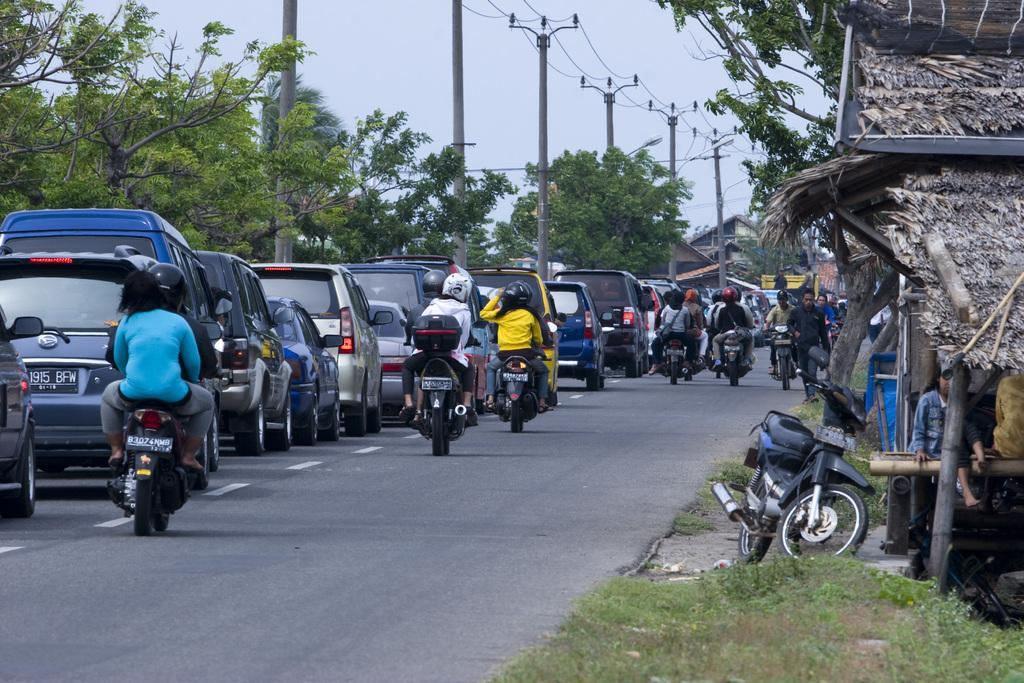What types of vehicles can be seen on the road in the image? Cars and bikes can be seen on the road in the image. What type of vegetation is present in the image? There is grass and trees in the image. What type of structure can be seen in the image? There is a hut in the image. Are there any people visible in the image? Yes, there are persons visible in the image. What else can be seen in the image besides the vehicles, vegetation, and structure? There are poles in the image. What is visible in the background of the image? The sky is visible in the background of the image. What day of the week is it in the image? The day of the week is not mentioned or visible in the image. Can you describe the sister of the person riding the bike in the image? There is no information about a sister or any specific person riding a bike in the image. 